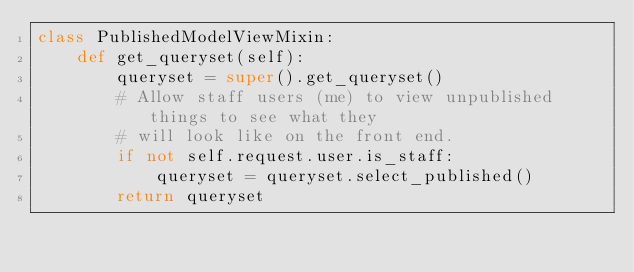<code> <loc_0><loc_0><loc_500><loc_500><_Python_>class PublishedModelViewMixin:
    def get_queryset(self):
        queryset = super().get_queryset()
        # Allow staff users (me) to view unpublished things to see what they
        # will look like on the front end.
        if not self.request.user.is_staff:
            queryset = queryset.select_published()
        return queryset
</code> 